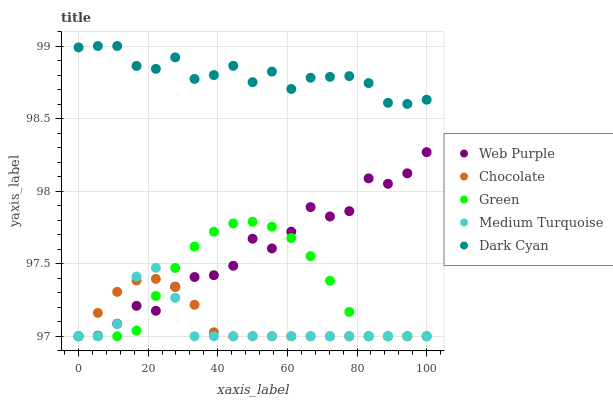Does Medium Turquoise have the minimum area under the curve?
Answer yes or no. Yes. Does Dark Cyan have the maximum area under the curve?
Answer yes or no. Yes. Does Web Purple have the minimum area under the curve?
Answer yes or no. No. Does Web Purple have the maximum area under the curve?
Answer yes or no. No. Is Chocolate the smoothest?
Answer yes or no. Yes. Is Web Purple the roughest?
Answer yes or no. Yes. Is Green the smoothest?
Answer yes or no. No. Is Green the roughest?
Answer yes or no. No. Does Web Purple have the lowest value?
Answer yes or no. Yes. Does Dark Cyan have the highest value?
Answer yes or no. Yes. Does Web Purple have the highest value?
Answer yes or no. No. Is Green less than Dark Cyan?
Answer yes or no. Yes. Is Dark Cyan greater than Chocolate?
Answer yes or no. Yes. Does Green intersect Web Purple?
Answer yes or no. Yes. Is Green less than Web Purple?
Answer yes or no. No. Is Green greater than Web Purple?
Answer yes or no. No. Does Green intersect Dark Cyan?
Answer yes or no. No. 